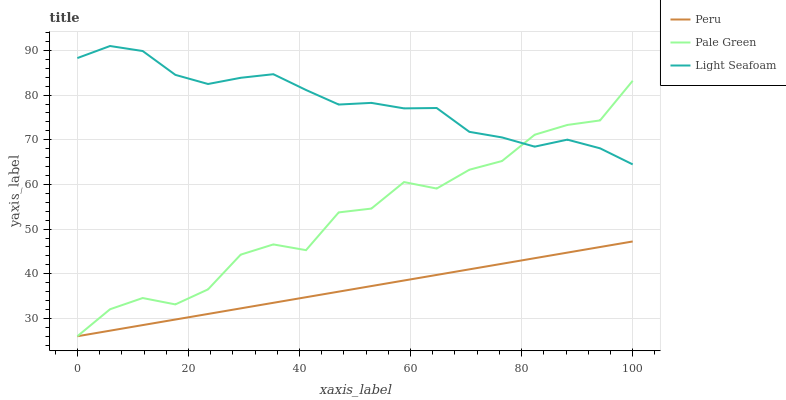Does Peru have the minimum area under the curve?
Answer yes or no. Yes. Does Light Seafoam have the maximum area under the curve?
Answer yes or no. Yes. Does Pale Green have the minimum area under the curve?
Answer yes or no. No. Does Pale Green have the maximum area under the curve?
Answer yes or no. No. Is Peru the smoothest?
Answer yes or no. Yes. Is Pale Green the roughest?
Answer yes or no. Yes. Is Pale Green the smoothest?
Answer yes or no. No. Is Peru the roughest?
Answer yes or no. No. Does Light Seafoam have the highest value?
Answer yes or no. Yes. Does Pale Green have the highest value?
Answer yes or no. No. Is Peru less than Light Seafoam?
Answer yes or no. Yes. Is Light Seafoam greater than Peru?
Answer yes or no. Yes. Does Pale Green intersect Light Seafoam?
Answer yes or no. Yes. Is Pale Green less than Light Seafoam?
Answer yes or no. No. Is Pale Green greater than Light Seafoam?
Answer yes or no. No. Does Peru intersect Light Seafoam?
Answer yes or no. No. 